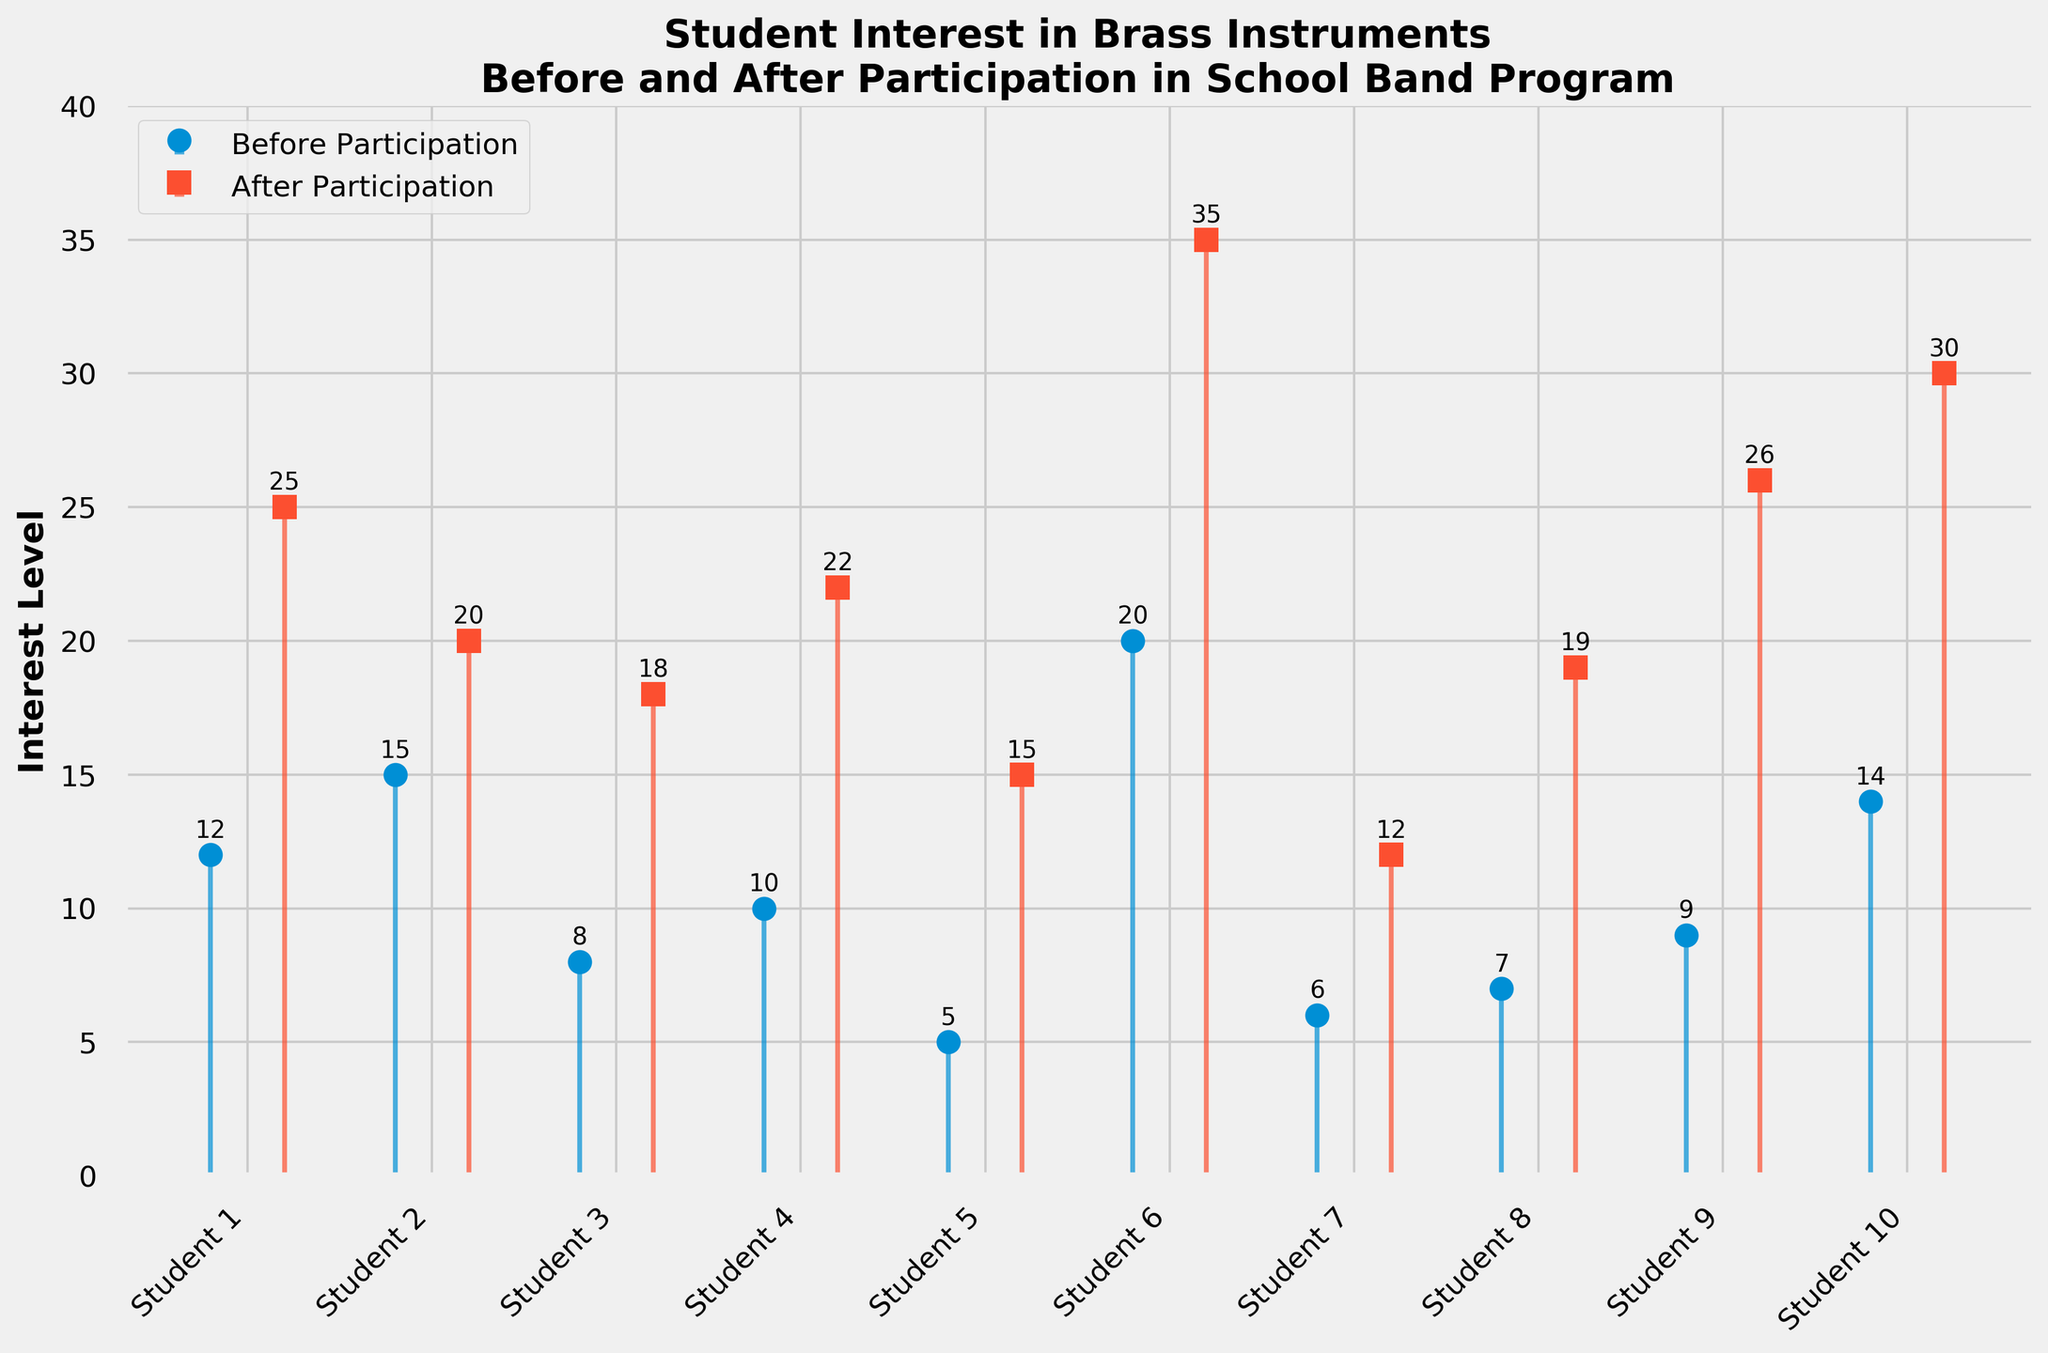What is the title of the figure? The title is usually found at the top of the figure, giving a summary of the data presented. In this case, it specifically mentions the observation of student interest in brass instruments before and after participation in a school band program.
Answer: Student Interest in Brass Instruments Before and After Participation in School Band Program What colors are used to distinguish 'Before Participation' and 'After Participation' in the plot? By visually inspecting the plot, you can distinguish two different colors used for the 'Before Participation' and 'After Participation' data points and lines. The 'Before Participation' data uses one color scheme, while 'After Participation' uses another.
Answer: Blue (Before) and Orange (After) How many students' interest levels were measured in the plot? To determine the number of students, observe the number of distinct data points or labels on the x-axis, which represent individual students.
Answer: 10 What was the highest interest level recorded before participation? Look for the tallest stem in the 'Before Participation' category and read the corresponding y-axis value.
Answer: 20 Which student showed the greatest increase in interest level? Calculate the difference between 'After Participation' and 'Before Participation' for each student and find the maximum value.
Answer: Student 6 What is the range of interest levels 'before participation'? Identify the minimum and maximum values for 'Before Participation' and compute the difference between them.
Answer: 20 - 5 = 15 For how many students did the interest level decrease after participation? Compare each student's 'Before Participation' and 'After Participation' values. Count the instances where the latter is smaller.
Answer: 0 What is the total interest level 'after participation' for all students combined? Sum up all the 'After Participation' values.
Answer: 242 On average, how much did the interest level increase after participating in the school band program? Find the differences for each student between 'After Participation' and 'Before Participation', then compute the average of these differences.
Answer: (25-12 + 20-15 + 18-8 + 22-10 + 15-5 + 35-20 + 12-6 + 19-7 + 26-9 + 30-14) / 10 = 112 / 10 = 11.2 What is the median interest level 'after participation'? Sort the 'After Participation' values and find the middle value (or the average of the two middle values if the number of data points is even).
Answer: 20.5 